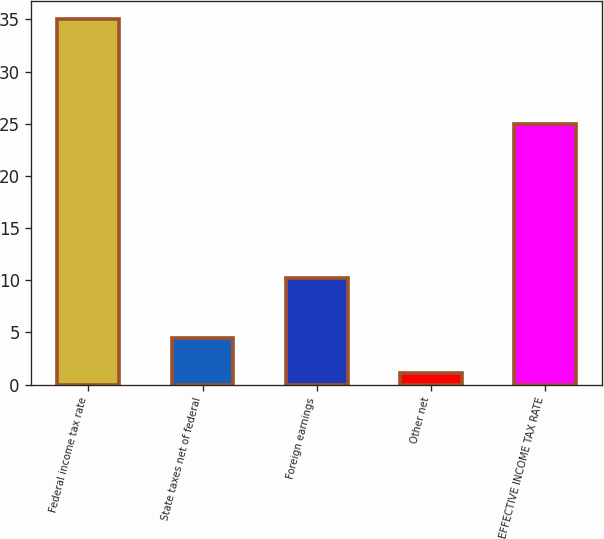<chart> <loc_0><loc_0><loc_500><loc_500><bar_chart><fcel>Federal income tax rate<fcel>State taxes net of federal<fcel>Foreign earnings<fcel>Other net<fcel>EFFECTIVE INCOME TAX RATE<nl><fcel>35<fcel>4.49<fcel>10.2<fcel>1.1<fcel>25<nl></chart> 